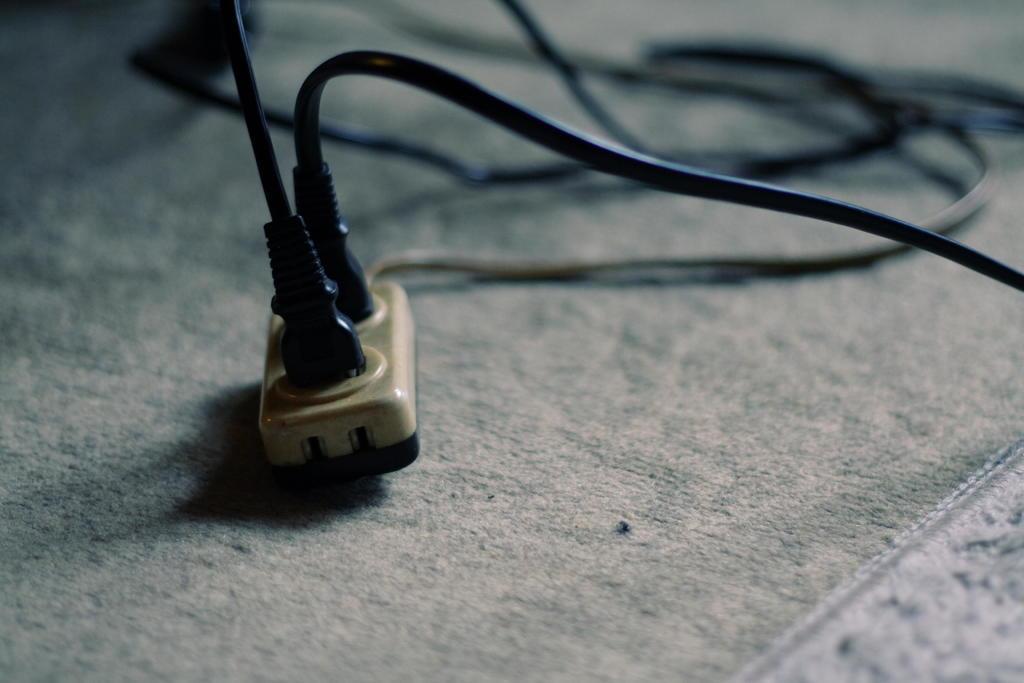Can you describe this image briefly? In this image I can see a plug board which is in brown color and I can also see two wires in black color. 